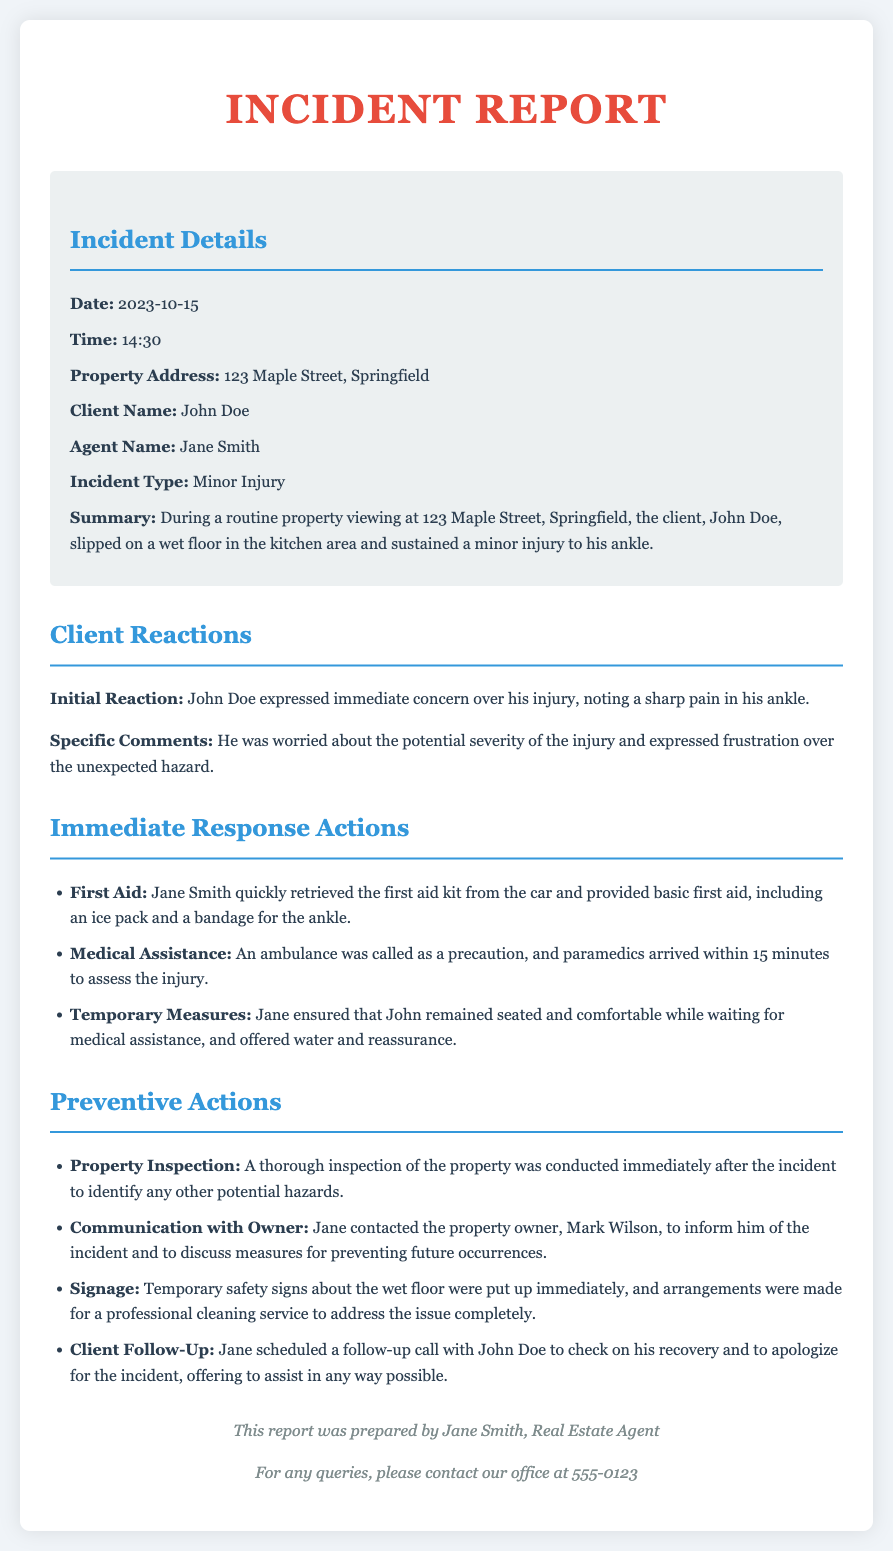What was the date of the incident? The incident occurred on October 15, 2023, which is specifically mentioned in the details section.
Answer: October 15, 2023 What time did the incident occur? The time of the incident is explicitly noted in the report as 14:30.
Answer: 14:30 Who was the client involved in the incident? The client is named John Doe, as noted in the incident details.
Answer: John Doe What type of injury did the client sustain? The document states that the incident type was a minor injury.
Answer: Minor Injury What immediate action did the agent take first? Jane Smith retrieved the first aid kit from the car, which is specified in the immediate response actions.
Answer: Retrieved the first aid kit How long did it take for the paramedics to arrive? The document mentions that paramedics arrived within 15 minutes.
Answer: 15 minutes What was done to inform about the wet floor? Temporary safety signs were put up immediately following the incident, as stated in the preventive actions.
Answer: Temporary safety signs What follow-up action did the agent take after the incident? Jane scheduled a follow-up call with John Doe to check on his recovery, which is outlined in the preventive actions.
Answer: Follow-up call What property was the incident related to? The incident report specifies that the property address is 123 Maple Street, Springfield.
Answer: 123 Maple Street, Springfield 